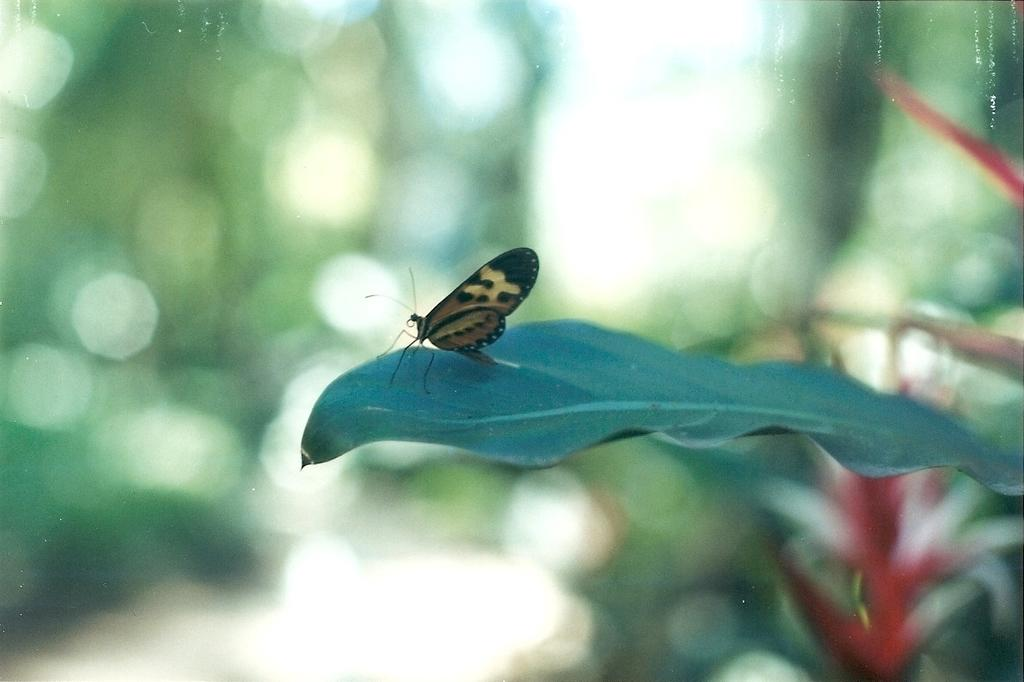What is the main subject of the image? There is a butterfly on a leaf in the image. What other natural elements can be seen in the image? There is a flower in the image. How would you describe the background of the image? The background of the image is blurred. What type of pickle is being used to water the flower in the image? There is no pickle present in the image, and the flower is not being watered. 